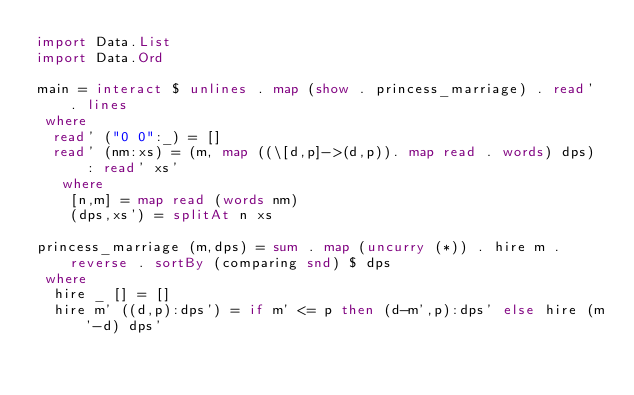Convert code to text. <code><loc_0><loc_0><loc_500><loc_500><_Haskell_>import Data.List
import Data.Ord

main = interact $ unlines . map (show . princess_marriage) . read' . lines
 where
  read' ("0 0":_) = []
  read' (nm:xs) = (m, map ((\[d,p]->(d,p)). map read . words) dps) : read' xs'
   where
    [n,m] = map read (words nm)
    (dps,xs') = splitAt n xs

princess_marriage (m,dps) = sum . map (uncurry (*)) . hire m . reverse . sortBy (comparing snd) $ dps
 where
  hire _ [] = []
  hire m' ((d,p):dps') = if m' <= p then (d-m',p):dps' else hire (m'-d) dps'</code> 